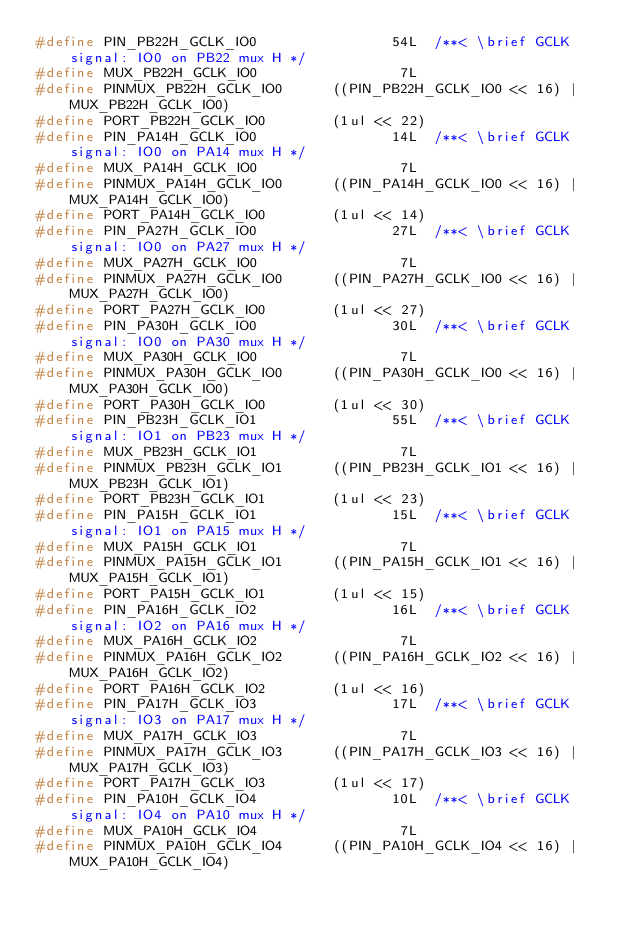Convert code to text. <code><loc_0><loc_0><loc_500><loc_500><_C_>#define PIN_PB22H_GCLK_IO0                54L  /**< \brief GCLK signal: IO0 on PB22 mux H */
#define MUX_PB22H_GCLK_IO0                 7L
#define PINMUX_PB22H_GCLK_IO0      ((PIN_PB22H_GCLK_IO0 << 16) | MUX_PB22H_GCLK_IO0)
#define PORT_PB22H_GCLK_IO0        (1ul << 22)
#define PIN_PA14H_GCLK_IO0                14L  /**< \brief GCLK signal: IO0 on PA14 mux H */
#define MUX_PA14H_GCLK_IO0                 7L
#define PINMUX_PA14H_GCLK_IO0      ((PIN_PA14H_GCLK_IO0 << 16) | MUX_PA14H_GCLK_IO0)
#define PORT_PA14H_GCLK_IO0        (1ul << 14)
#define PIN_PA27H_GCLK_IO0                27L  /**< \brief GCLK signal: IO0 on PA27 mux H */
#define MUX_PA27H_GCLK_IO0                 7L
#define PINMUX_PA27H_GCLK_IO0      ((PIN_PA27H_GCLK_IO0 << 16) | MUX_PA27H_GCLK_IO0)
#define PORT_PA27H_GCLK_IO0        (1ul << 27)
#define PIN_PA30H_GCLK_IO0                30L  /**< \brief GCLK signal: IO0 on PA30 mux H */
#define MUX_PA30H_GCLK_IO0                 7L
#define PINMUX_PA30H_GCLK_IO0      ((PIN_PA30H_GCLK_IO0 << 16) | MUX_PA30H_GCLK_IO0)
#define PORT_PA30H_GCLK_IO0        (1ul << 30)
#define PIN_PB23H_GCLK_IO1                55L  /**< \brief GCLK signal: IO1 on PB23 mux H */
#define MUX_PB23H_GCLK_IO1                 7L
#define PINMUX_PB23H_GCLK_IO1      ((PIN_PB23H_GCLK_IO1 << 16) | MUX_PB23H_GCLK_IO1)
#define PORT_PB23H_GCLK_IO1        (1ul << 23)
#define PIN_PA15H_GCLK_IO1                15L  /**< \brief GCLK signal: IO1 on PA15 mux H */
#define MUX_PA15H_GCLK_IO1                 7L
#define PINMUX_PA15H_GCLK_IO1      ((PIN_PA15H_GCLK_IO1 << 16) | MUX_PA15H_GCLK_IO1)
#define PORT_PA15H_GCLK_IO1        (1ul << 15)
#define PIN_PA16H_GCLK_IO2                16L  /**< \brief GCLK signal: IO2 on PA16 mux H */
#define MUX_PA16H_GCLK_IO2                 7L
#define PINMUX_PA16H_GCLK_IO2      ((PIN_PA16H_GCLK_IO2 << 16) | MUX_PA16H_GCLK_IO2)
#define PORT_PA16H_GCLK_IO2        (1ul << 16)
#define PIN_PA17H_GCLK_IO3                17L  /**< \brief GCLK signal: IO3 on PA17 mux H */
#define MUX_PA17H_GCLK_IO3                 7L
#define PINMUX_PA17H_GCLK_IO3      ((PIN_PA17H_GCLK_IO3 << 16) | MUX_PA17H_GCLK_IO3)
#define PORT_PA17H_GCLK_IO3        (1ul << 17)
#define PIN_PA10H_GCLK_IO4                10L  /**< \brief GCLK signal: IO4 on PA10 mux H */
#define MUX_PA10H_GCLK_IO4                 7L
#define PINMUX_PA10H_GCLK_IO4      ((PIN_PA10H_GCLK_IO4 << 16) | MUX_PA10H_GCLK_IO4)</code> 